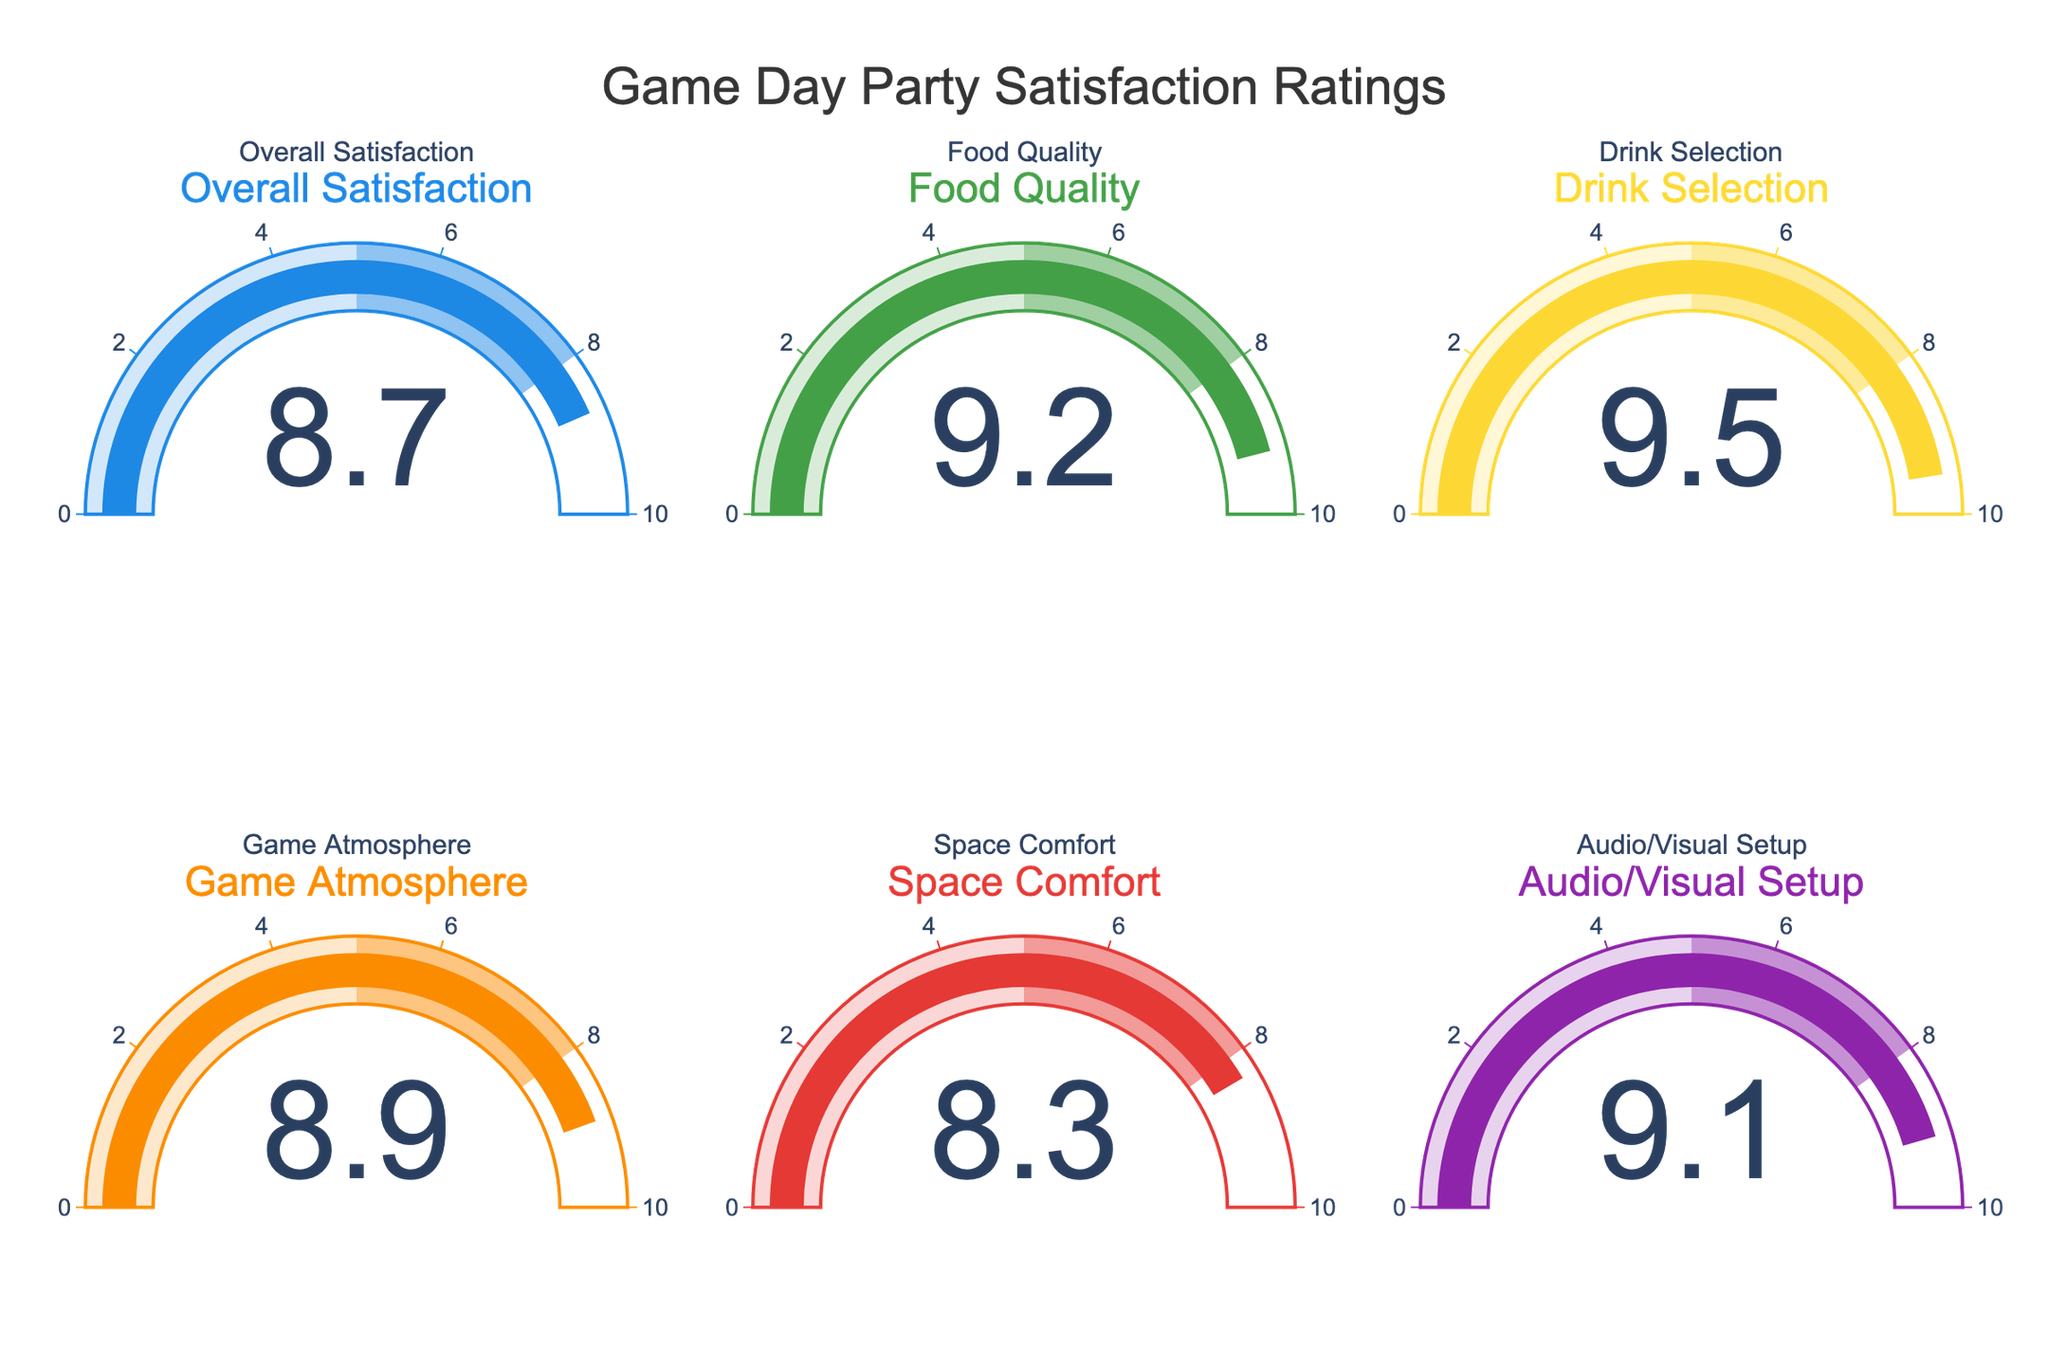Which rating has the highest value? By observing the gauge chart, identify the needle pointing to the largest number. The "Drink Selection" rating shows the highest value at 9.5.
Answer: Drink Selection Which rating has the lowest value? Look for the needle that points to the smallest value among the charts. The "Space Comfort" rating has the lowest value at 8.3.
Answer: Space Comfort What's the average value of all the ratings? Sum up all the values and divide by the number of ratings: (8.7 + 9.2 + 9.5 + 8.9 + 8.3 + 9.1) / 6 = 53.7 / 6 = 8.95.
Answer: 8.95 What's the difference between the highest and lowest rating values? Subtract the smallest value from the largest value: 9.5 (highest) - 8.3 (lowest) = 1.2.
Answer: 1.2 If the average rating is considered satisfactory if it's above 9, is the average rating of your party satisfactory? From the previous calculation, the average value is 8.95 which is below 9, thus it is not considered satisfactory.
Answer: No Which rating is closest to the overall satisfaction value? Overall Satisfaction has a value of 8.7. Compare this with each rating value: 
- Food Quality: 9.2,
- Drink Selection: 9.5,
- Game Atmosphere: 8.9,
- Space Comfort: 8.3,
- Audio/Visual Setup: 9.1.
8.9 (Game Atmosphere) is the closest to 8.7.
Answer: Game Atmosphere How many ratings are above 9? Identify the gauge charts with values greater than 9: Food Quality (9.2), Drink Selection (9.5), and Audio/Visual Setup (9.1). There are 3 such ratings.
Answer: 3 Which ratings had values between 8 and 9? Check the gauge charts and identify which values fall between 8 and 9: Overall Satisfaction (8.7), Game Atmosphere (8.9), and Space Comfort (8.3).
Answer: 3 (Overall Satisfaction, Game Atmosphere, Space Comfort) What is the difference between Food Quality and Space Comfort ratings? Subtract the value of Space Comfort from the value of Food Quality: 9.2 - 8.3 = 0.9.
Answer: 0.9 